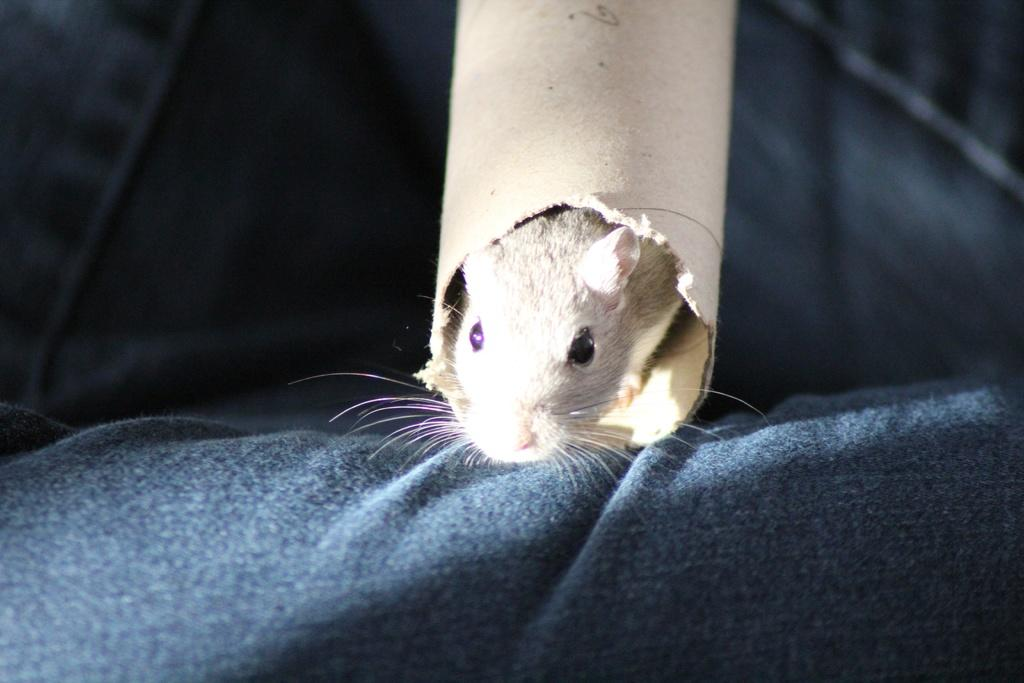What is at the bottom of the image? There is a cloth at the bottom of the image. What is happening at the top of the image? There is a rat inside a pole at the top of the image. Can you describe the background of the image? The background of the image is blurred. How many fingers can be seen holding the cloth in the image? There are no fingers visible in the image; it only shows a cloth at the bottom and a rat inside a pole at the top. What type of rake is being used to clean the background in the image? There is no rake present in the image, and the background is blurred, not requiring cleaning. 